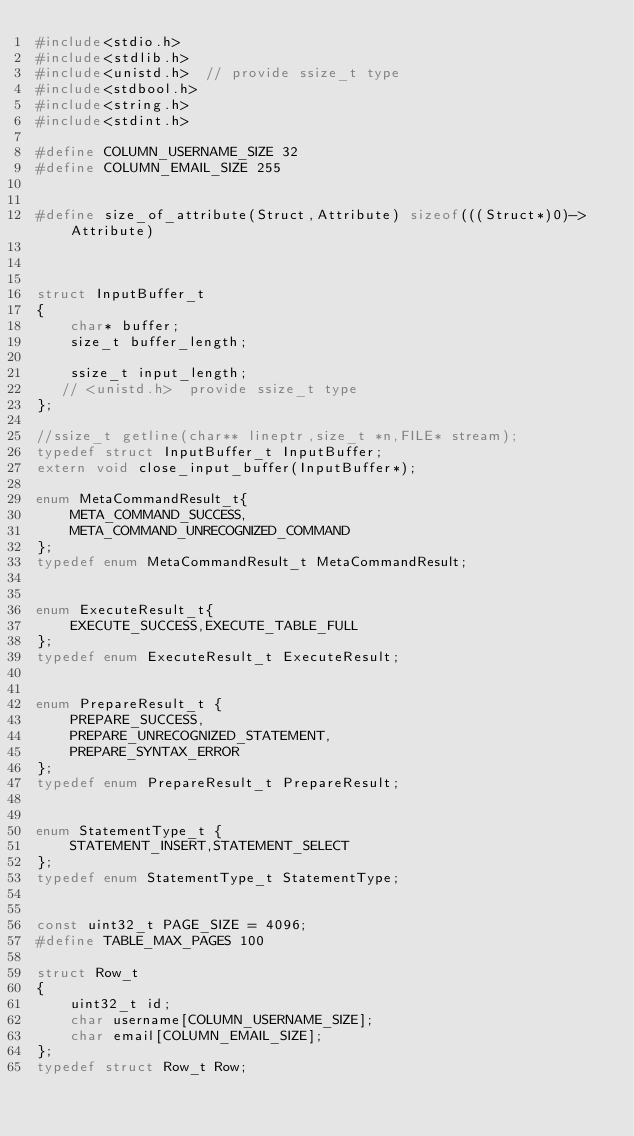Convert code to text. <code><loc_0><loc_0><loc_500><loc_500><_C_>#include<stdio.h>
#include<stdlib.h>
#include<unistd.h>  // provide ssize_t type
#include<stdbool.h>
#include<string.h>
#include<stdint.h>

#define COLUMN_USERNAME_SIZE 32
#define COLUMN_EMAIL_SIZE 255


#define size_of_attribute(Struct,Attribute) sizeof(((Struct*)0)->Attribute)



struct InputBuffer_t
{   
    char* buffer;
    size_t buffer_length;

    ssize_t input_length;
   // <unistd.h>  provide ssize_t type
};

//ssize_t getline(char** lineptr,size_t *n,FILE* stream);
typedef struct InputBuffer_t InputBuffer;
extern void close_input_buffer(InputBuffer*);

enum MetaCommandResult_t{
    META_COMMAND_SUCCESS,
    META_COMMAND_UNRECOGNIZED_COMMAND
};
typedef enum MetaCommandResult_t MetaCommandResult;


enum ExecuteResult_t{
    EXECUTE_SUCCESS,EXECUTE_TABLE_FULL
};
typedef enum ExecuteResult_t ExecuteResult;


enum PrepareResult_t {
    PREPARE_SUCCESS,
    PREPARE_UNRECOGNIZED_STATEMENT,
    PREPARE_SYNTAX_ERROR
};
typedef enum PrepareResult_t PrepareResult;


enum StatementType_t {
    STATEMENT_INSERT,STATEMENT_SELECT
};
typedef enum StatementType_t StatementType;


const uint32_t PAGE_SIZE = 4096;
#define TABLE_MAX_PAGES 100

struct Row_t
{
    uint32_t id;
    char username[COLUMN_USERNAME_SIZE];
    char email[COLUMN_EMAIL_SIZE];
};
typedef struct Row_t Row;
</code> 